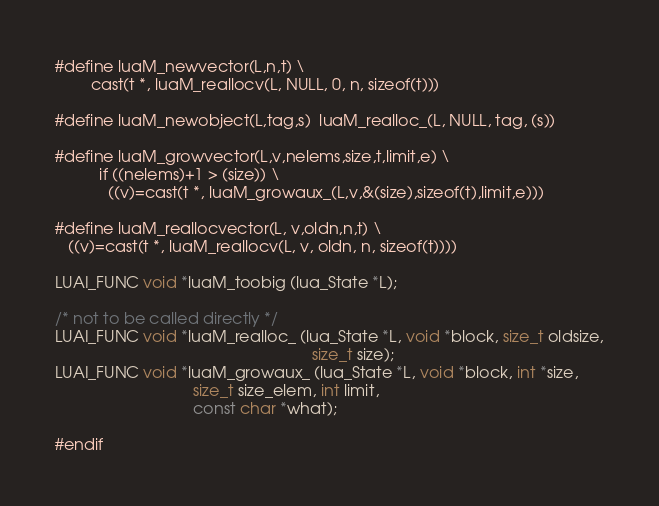<code> <loc_0><loc_0><loc_500><loc_500><_C_>#define luaM_newvector(L,n,t) \
		cast(t *, luaM_reallocv(L, NULL, 0, n, sizeof(t)))

#define luaM_newobject(L,tag,s)	luaM_realloc_(L, NULL, tag, (s))

#define luaM_growvector(L,v,nelems,size,t,limit,e) \
          if ((nelems)+1 > (size)) \
            ((v)=cast(t *, luaM_growaux_(L,v,&(size),sizeof(t),limit,e)))

#define luaM_reallocvector(L, v,oldn,n,t) \
   ((v)=cast(t *, luaM_reallocv(L, v, oldn, n, sizeof(t))))

LUAI_FUNC void *luaM_toobig (lua_State *L);

/* not to be called directly */
LUAI_FUNC void *luaM_realloc_ (lua_State *L, void *block, size_t oldsize,
                                                          size_t size);
LUAI_FUNC void *luaM_growaux_ (lua_State *L, void *block, int *size,
                               size_t size_elem, int limit,
                               const char *what);

#endif

</code> 